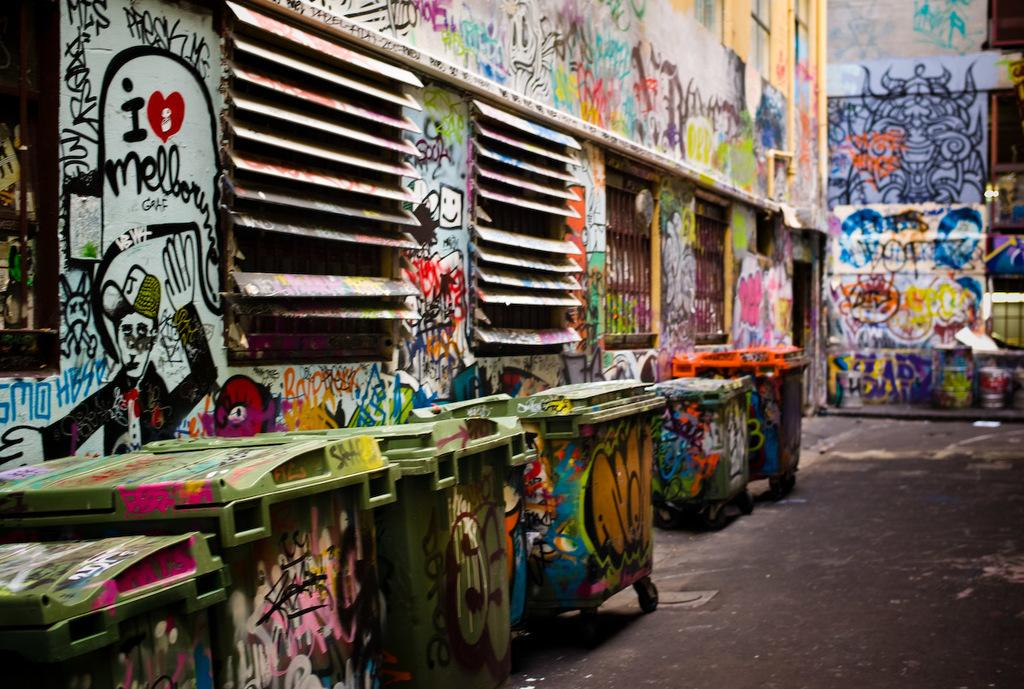<image>
Create a compact narrative representing the image presented. an ally and dumpsters are covered with a lot of graffiti and someone loves mellorime 